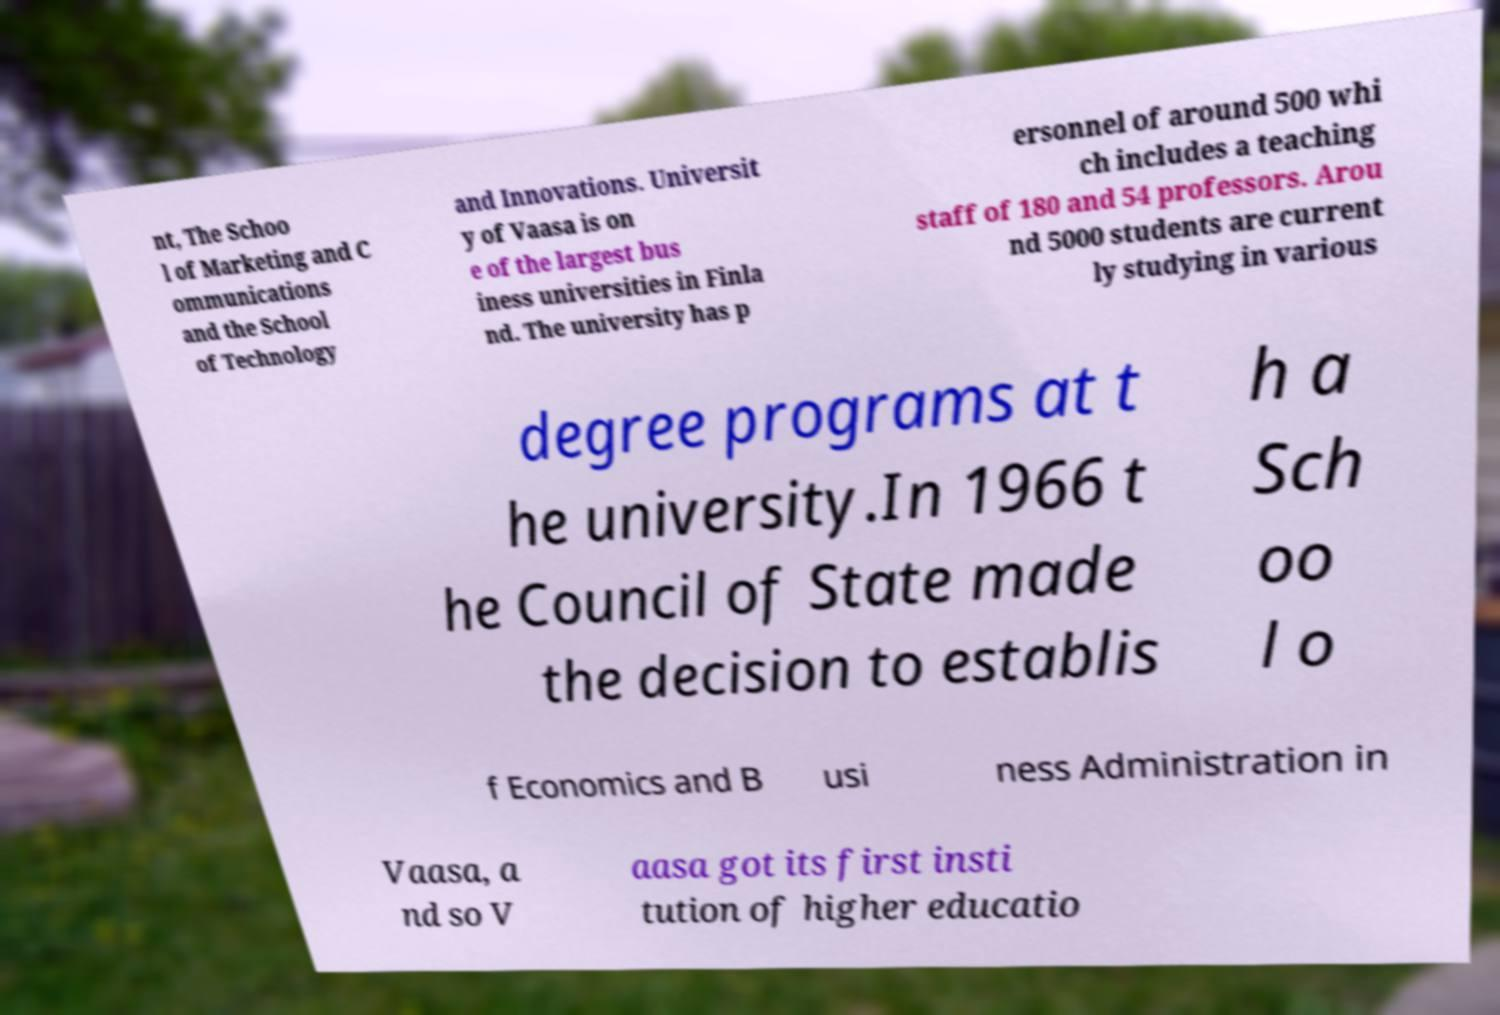There's text embedded in this image that I need extracted. Can you transcribe it verbatim? nt, The Schoo l of Marketing and C ommunications and the School of Technology and Innovations. Universit y of Vaasa is on e of the largest bus iness universities in Finla nd. The university has p ersonnel of around 500 whi ch includes a teaching staff of 180 and 54 professors. Arou nd 5000 students are current ly studying in various degree programs at t he university.In 1966 t he Council of State made the decision to establis h a Sch oo l o f Economics and B usi ness Administration in Vaasa, a nd so V aasa got its first insti tution of higher educatio 